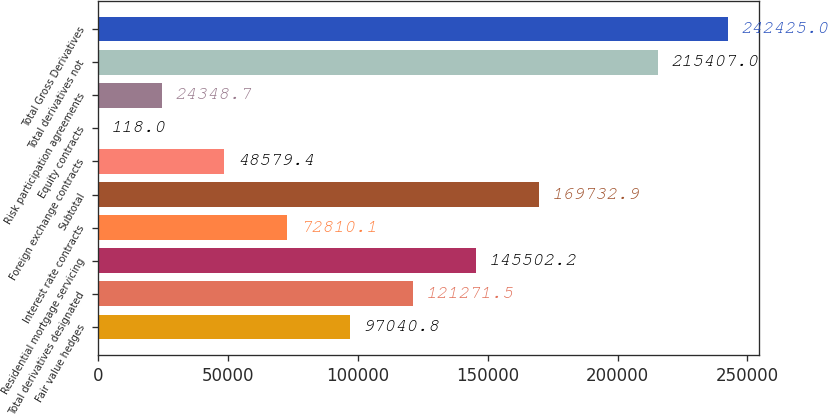<chart> <loc_0><loc_0><loc_500><loc_500><bar_chart><fcel>Fair value hedges<fcel>Total derivatives designated<fcel>Residential mortgage servicing<fcel>Interest rate contracts<fcel>Subtotal<fcel>Foreign exchange contracts<fcel>Equity contracts<fcel>Risk participation agreements<fcel>Total derivatives not<fcel>Total Gross Derivatives<nl><fcel>97040.8<fcel>121272<fcel>145502<fcel>72810.1<fcel>169733<fcel>48579.4<fcel>118<fcel>24348.7<fcel>215407<fcel>242425<nl></chart> 